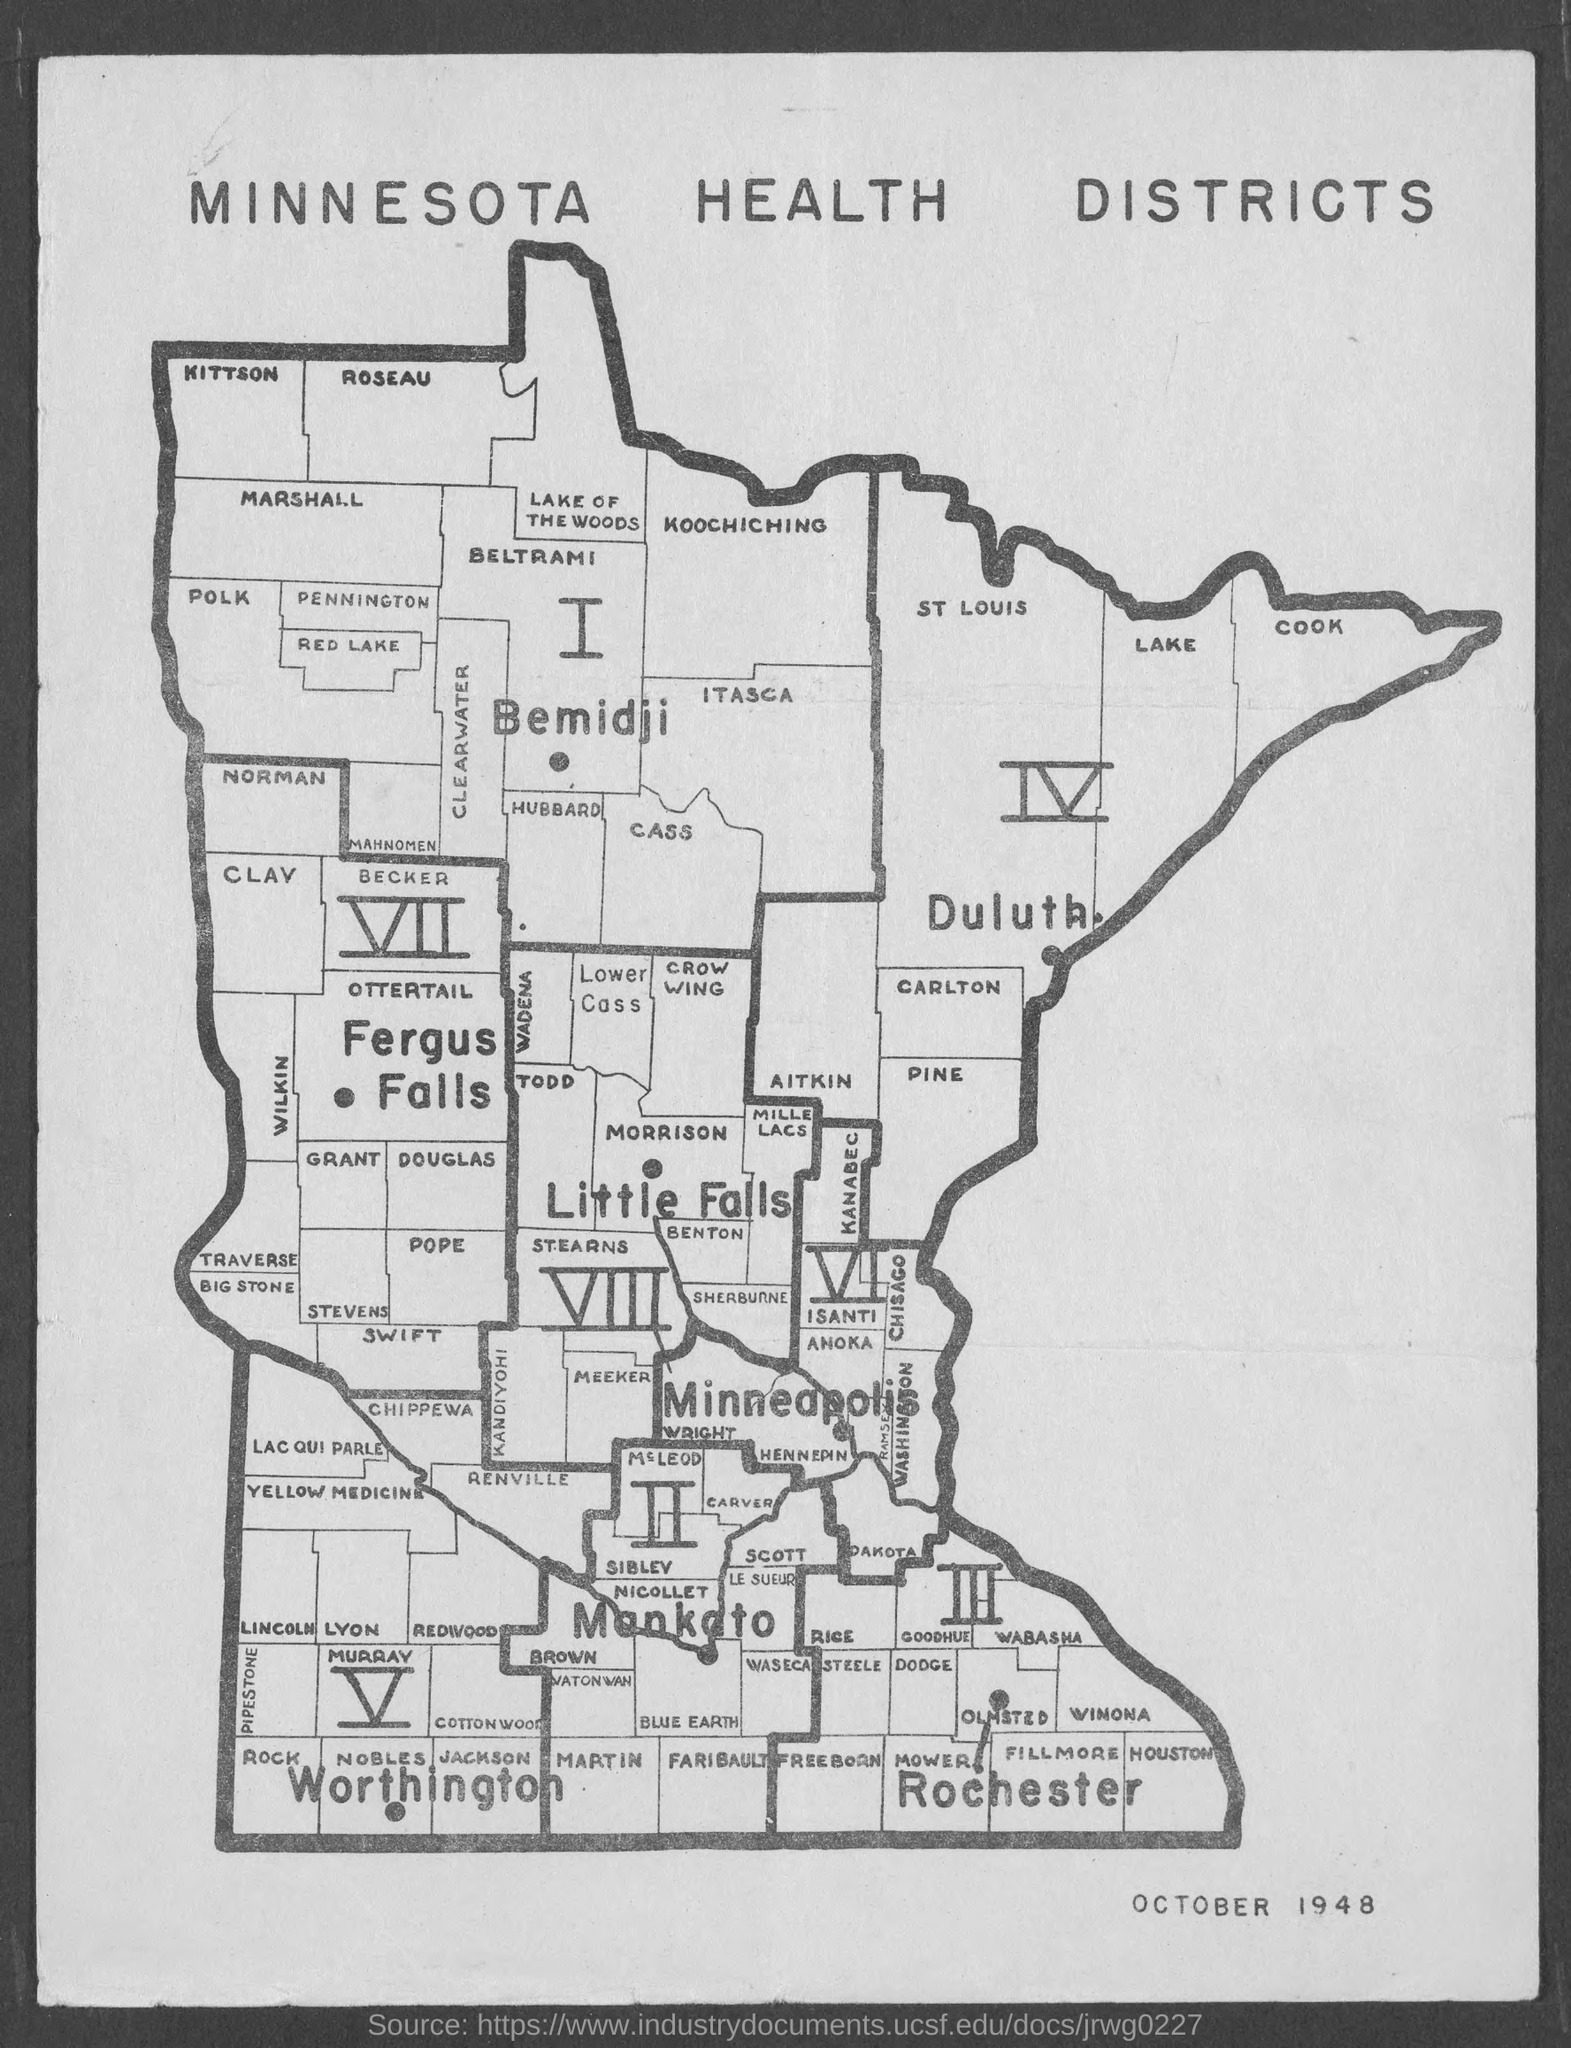What map is it?
Your response must be concise. Minnesota health districts. What is the month and year mentioned at the bottom?
Offer a very short reply. October 1948. 